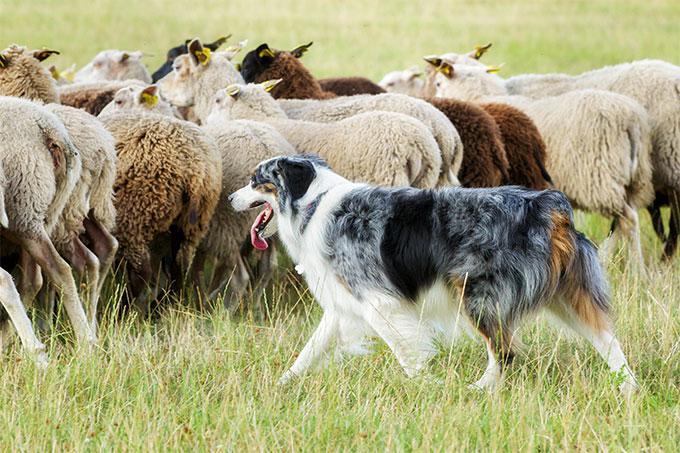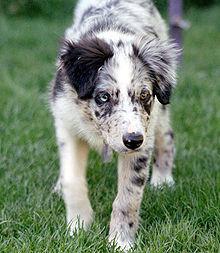The first image is the image on the left, the second image is the image on the right. For the images displayed, is the sentence "The left image depicts only a canine-type animal on the grass." factually correct? Answer yes or no. No. 